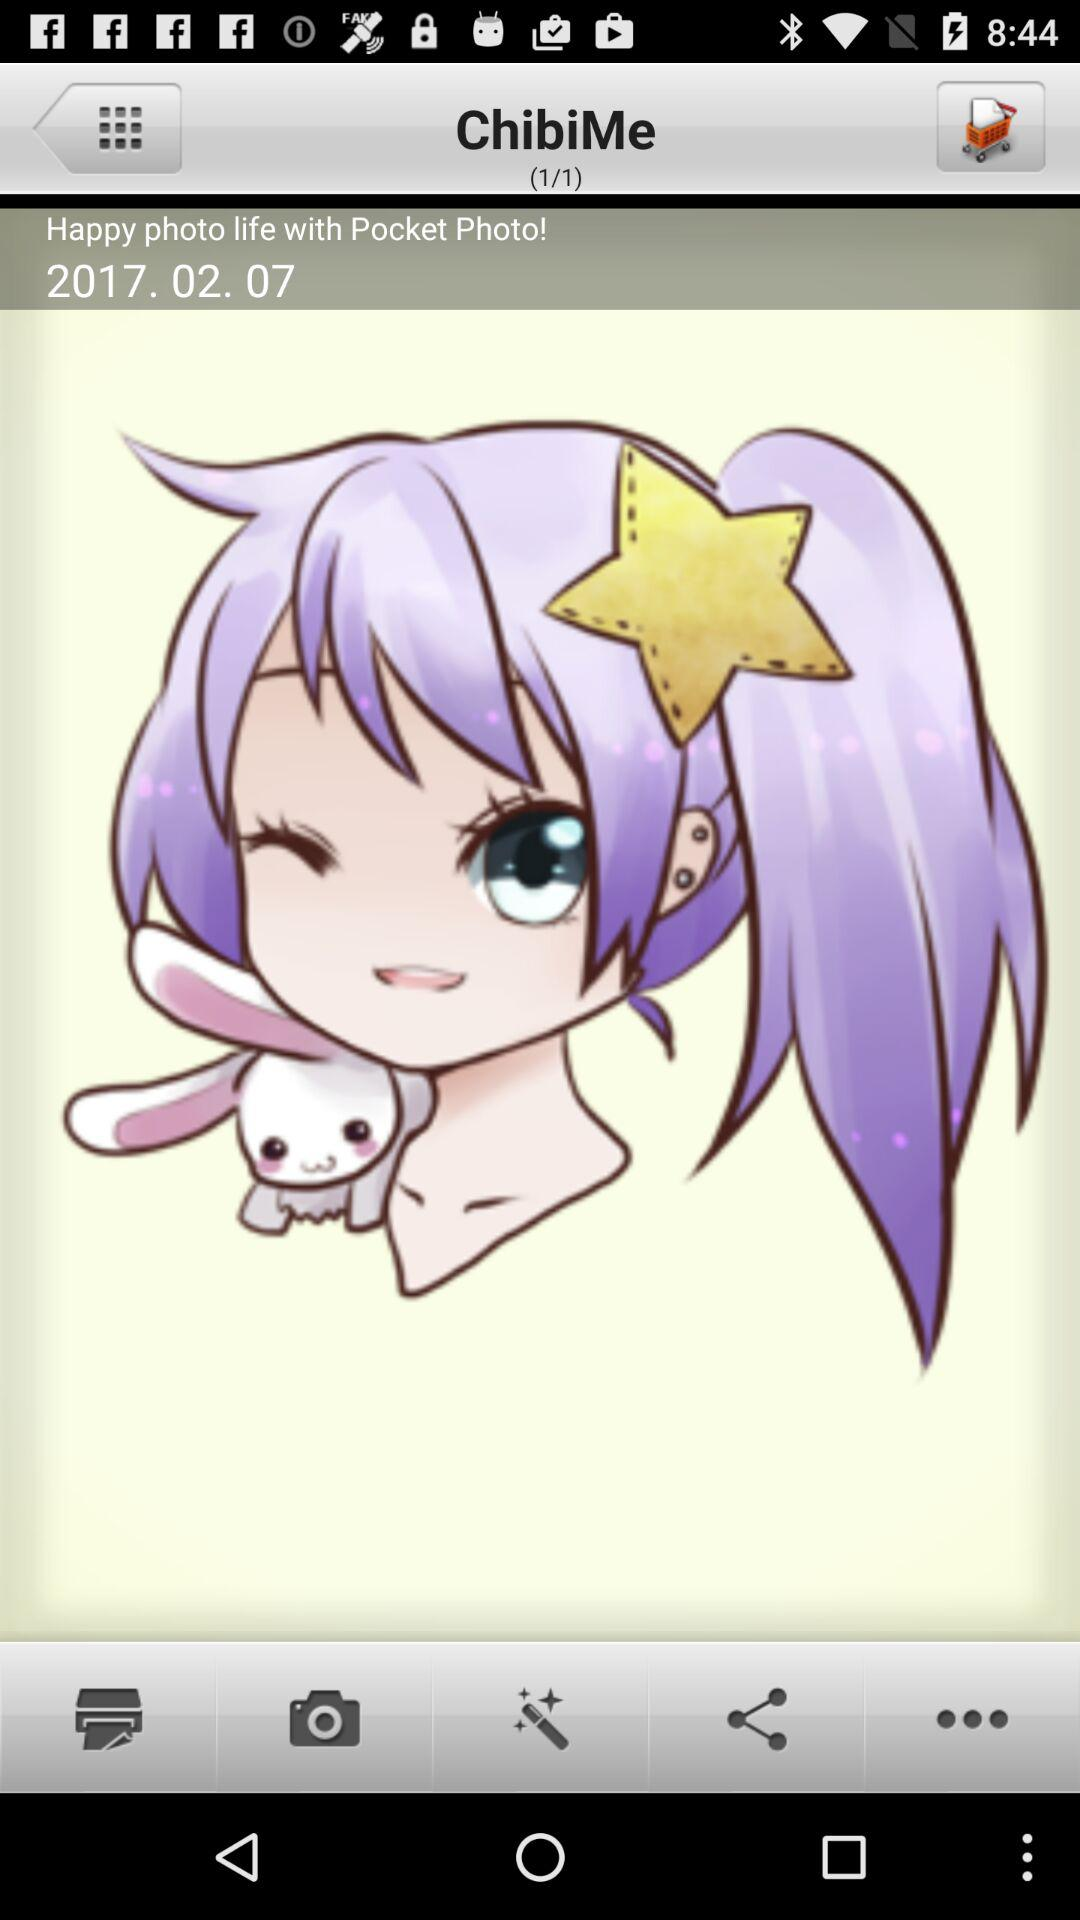How many images are there in total? There is 1 image in total. 